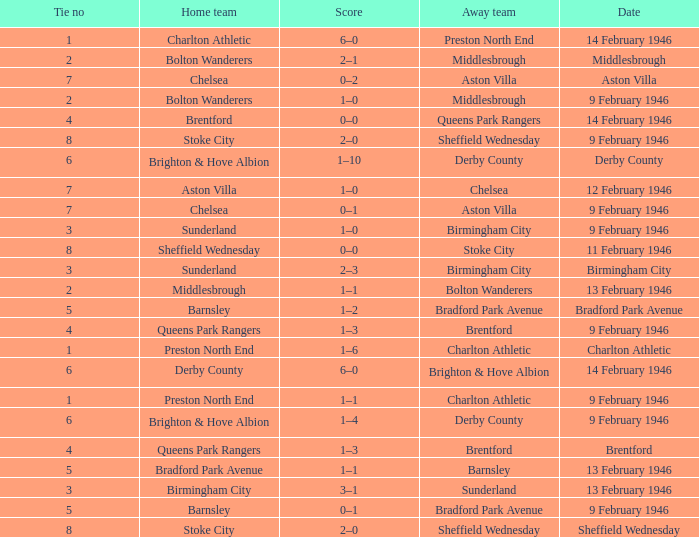What was the Tie no when then home team was Stoke City for the game played on 9 February 1946? 8.0. 